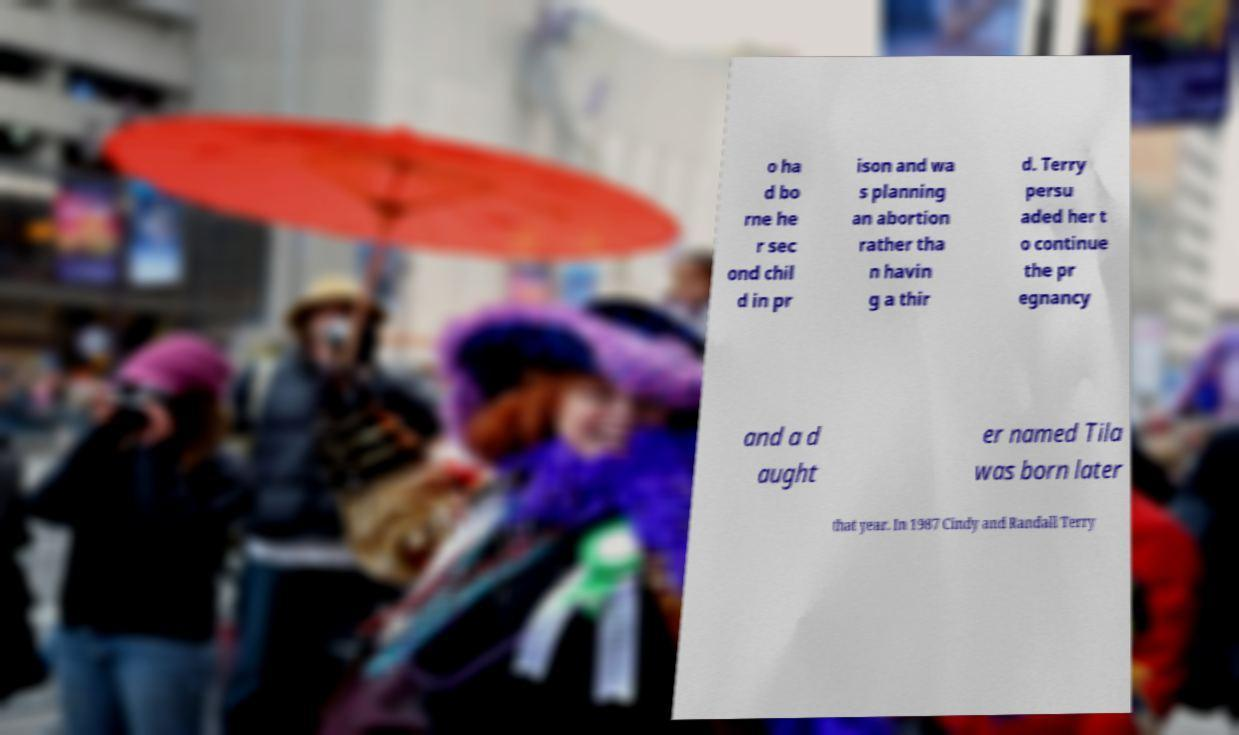Can you read and provide the text displayed in the image?This photo seems to have some interesting text. Can you extract and type it out for me? o ha d bo rne he r sec ond chil d in pr ison and wa s planning an abortion rather tha n havin g a thir d. Terry persu aded her t o continue the pr egnancy and a d aught er named Tila was born later that year. In 1987 Cindy and Randall Terry 